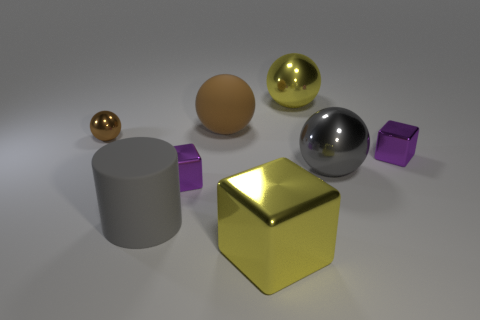Subtract all small shiny blocks. How many blocks are left? 1 Add 1 rubber balls. How many objects exist? 9 Subtract 1 balls. How many balls are left? 3 Subtract all yellow blocks. Subtract all purple cylinders. How many blocks are left? 2 Subtract all cyan cubes. How many brown cylinders are left? 0 Subtract all matte objects. Subtract all matte cylinders. How many objects are left? 5 Add 8 big gray metallic objects. How many big gray metallic objects are left? 9 Add 4 green things. How many green things exist? 4 Subtract all purple blocks. How many blocks are left? 1 Subtract 0 purple cylinders. How many objects are left? 8 